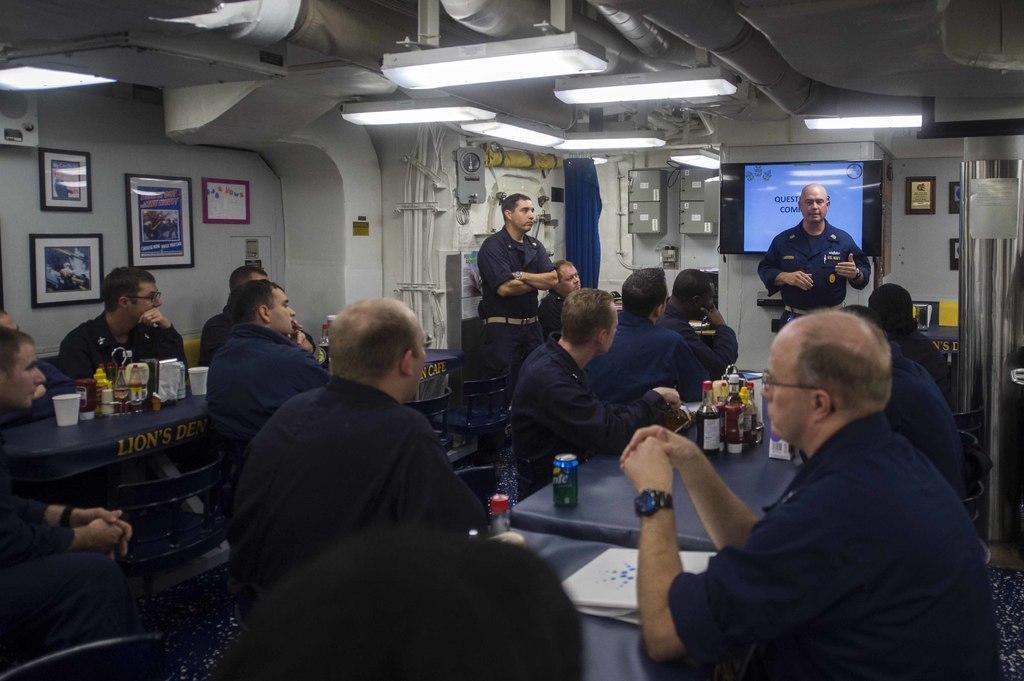How would you summarize this image in a sentence or two? It is a meeting, many people were sitting around the tables and in front of them a person is standing and talking, behind him there is a screen and something is being displayed on the screen. On the tables there are sauces, drinks and other items, on the left side there are few photo frames attached to the wall and beside that there are many other equipment fixed to the wall and roof of a room. 